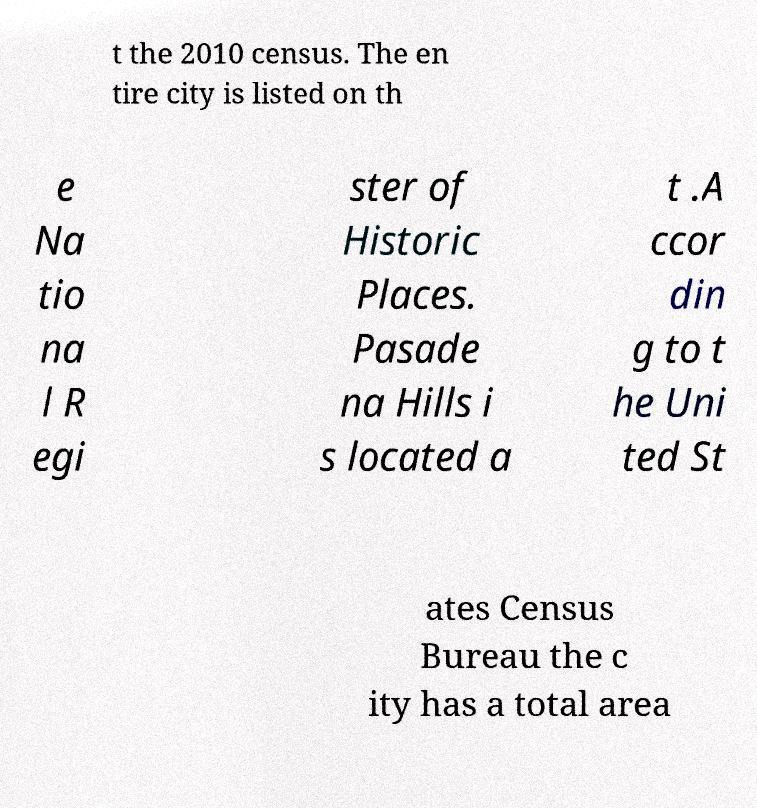I need the written content from this picture converted into text. Can you do that? t the 2010 census. The en tire city is listed on th e Na tio na l R egi ster of Historic Places. Pasade na Hills i s located a t .A ccor din g to t he Uni ted St ates Census Bureau the c ity has a total area 